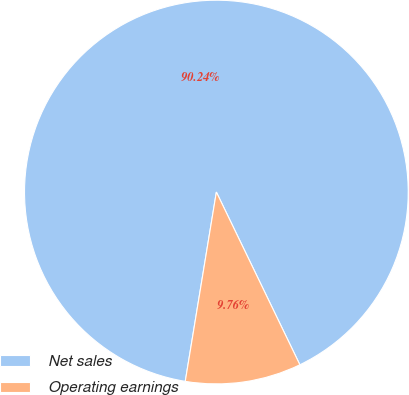Convert chart to OTSL. <chart><loc_0><loc_0><loc_500><loc_500><pie_chart><fcel>Net sales<fcel>Operating earnings<nl><fcel>90.24%<fcel>9.76%<nl></chart> 